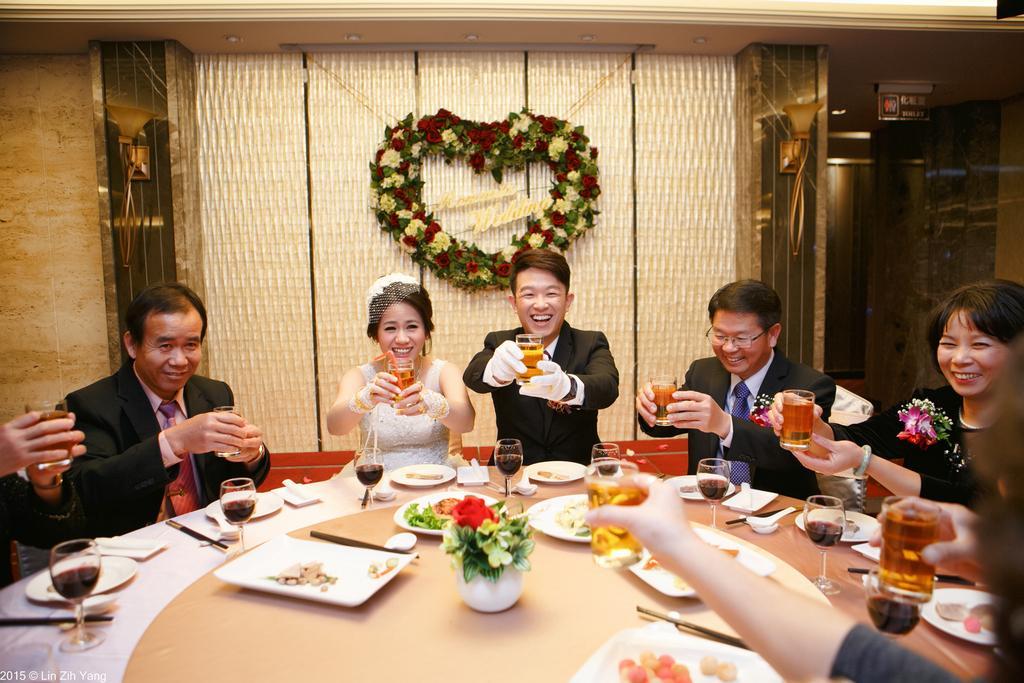Can you describe this image briefly? In the image we can see there are lot of people who are sitting and they are holding a wine glass in their hand. On the table there are tray on which there are food items kept. 